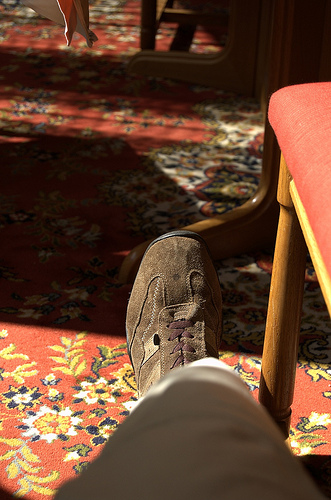<image>
Can you confirm if the shoe is on the floor mat? Yes. Looking at the image, I can see the shoe is positioned on top of the floor mat, with the floor mat providing support. Is there a person in front of the shadow? Yes. The person is positioned in front of the shadow, appearing closer to the camera viewpoint. 